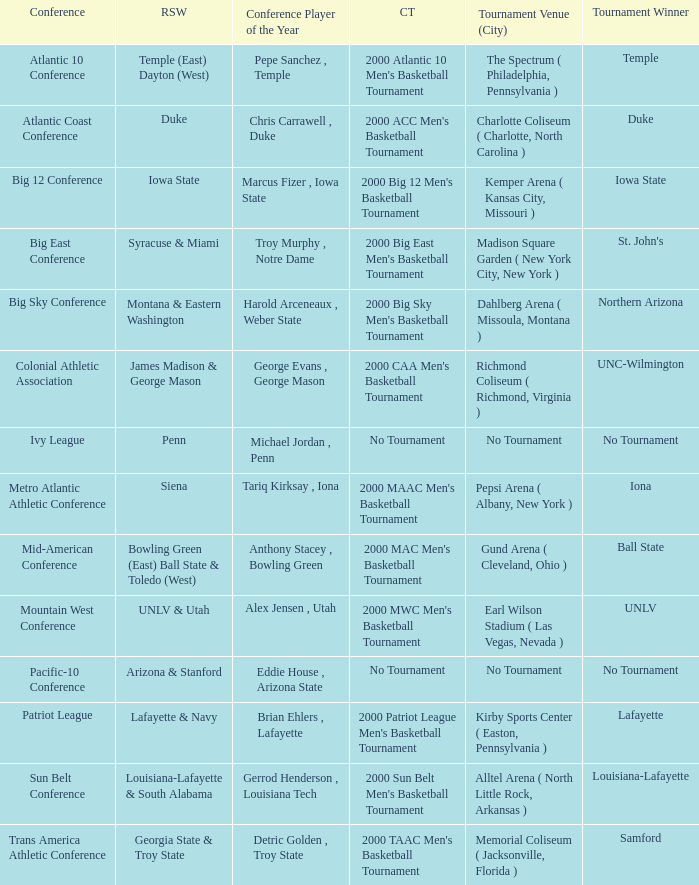Who is the regular season winner for the Ivy League conference? Penn. 